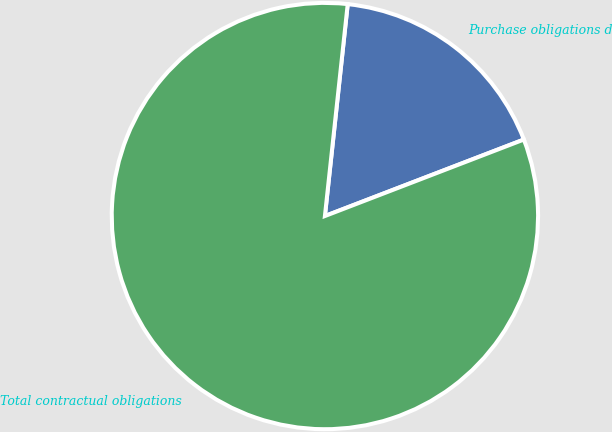Convert chart to OTSL. <chart><loc_0><loc_0><loc_500><loc_500><pie_chart><fcel>Purchase obligations d<fcel>Total contractual obligations<nl><fcel>17.45%<fcel>82.55%<nl></chart> 